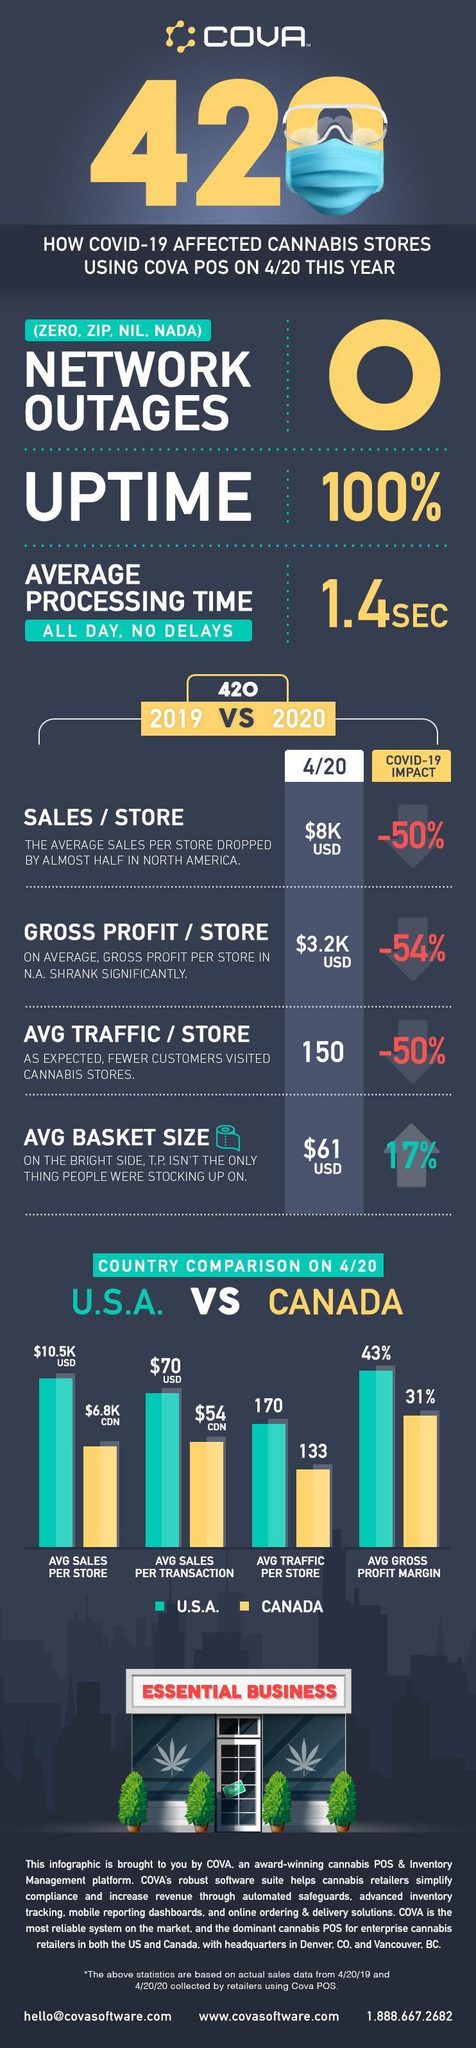Which country has more avg traffic per store- U.S.A. or Canada?
Answer the question with a short phrase. U.S.A. What is the difference in avg gross profit margin beyween USA and Canada? 12% 